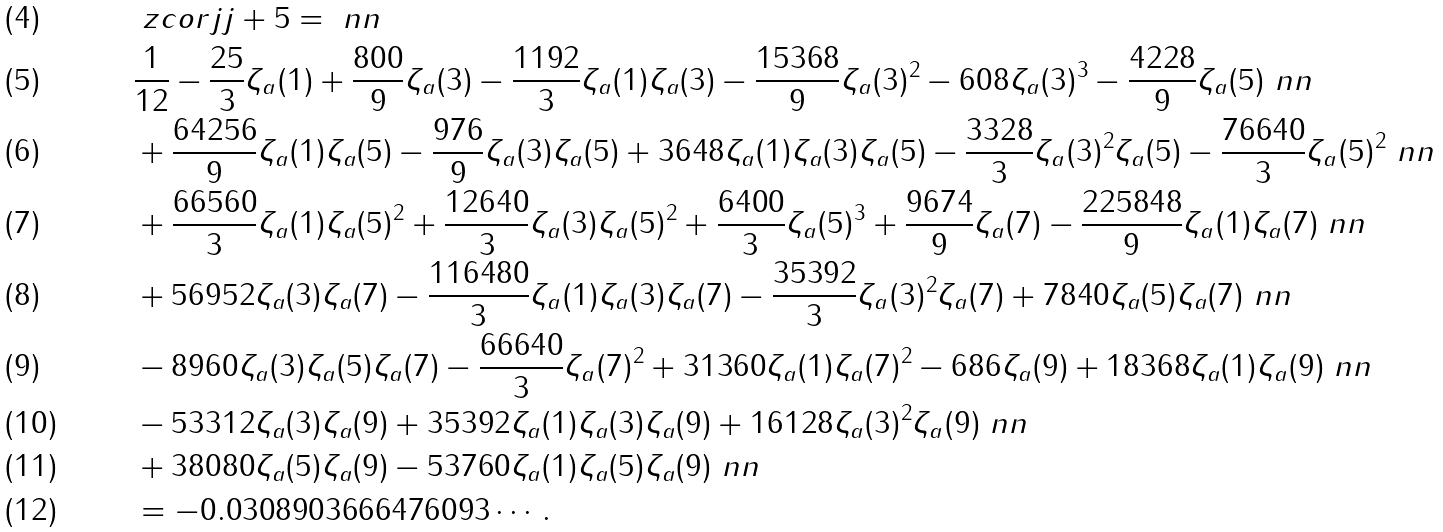Convert formula to latex. <formula><loc_0><loc_0><loc_500><loc_500>& \ z c o r { j } { j + 5 } = \ n n \\ & \frac { 1 } { 1 2 } - \frac { 2 5 } { 3 } \zeta _ { a } ( 1 ) + \frac { 8 0 0 } { 9 } \zeta _ { a } ( 3 ) - \frac { 1 1 9 2 } { 3 } \zeta _ { a } ( 1 ) \zeta _ { a } ( 3 ) - \frac { 1 5 3 6 8 } { 9 } \zeta _ { a } ( 3 ) ^ { 2 } - 6 0 8 \zeta _ { a } ( 3 ) ^ { 3 } - \frac { 4 2 2 8 } { 9 } \zeta _ { a } ( 5 ) \ n n \\ & + \frac { 6 4 2 5 6 } { 9 } \zeta _ { a } ( 1 ) \zeta _ { a } ( 5 ) - \frac { 9 7 6 } { 9 } \zeta _ { a } ( 3 ) \zeta _ { a } ( 5 ) + 3 6 4 8 \zeta _ { a } ( 1 ) \zeta _ { a } ( 3 ) \zeta _ { a } ( 5 ) - \frac { 3 3 2 8 } { 3 } \zeta _ { a } ( 3 ) ^ { 2 } \zeta _ { a } ( 5 ) - \frac { 7 6 6 4 0 } { 3 } \zeta _ { a } ( 5 ) ^ { 2 } \ n n \\ & + \frac { 6 6 5 6 0 } { 3 } \zeta _ { a } ( 1 ) \zeta _ { a } ( 5 ) ^ { 2 } + \frac { 1 2 6 4 0 } { 3 } \zeta _ { a } ( 3 ) \zeta _ { a } ( 5 ) ^ { 2 } + \frac { 6 4 0 0 } { 3 } \zeta _ { a } ( 5 ) ^ { 3 } + \frac { 9 6 7 4 } { 9 } \zeta _ { a } ( 7 ) - \frac { 2 2 5 8 4 8 } { 9 } \zeta _ { a } ( 1 ) \zeta _ { a } ( 7 ) \ n n \\ & + 5 6 9 5 2 \zeta _ { a } ( 3 ) \zeta _ { a } ( 7 ) - \frac { 1 1 6 4 8 0 } { 3 } \zeta _ { a } ( 1 ) \zeta _ { a } ( 3 ) \zeta _ { a } ( 7 ) - \frac { 3 5 3 9 2 } { 3 } \zeta _ { a } ( 3 ) ^ { 2 } \zeta _ { a } ( 7 ) + 7 8 4 0 \zeta _ { a } ( 5 ) \zeta _ { a } ( 7 ) \ n n \\ & - 8 9 6 0 \zeta _ { a } ( 3 ) \zeta _ { a } ( 5 ) \zeta _ { a } ( 7 ) - \frac { 6 6 6 4 0 } { 3 } \zeta _ { a } ( 7 ) ^ { 2 } + 3 1 3 6 0 \zeta _ { a } ( 1 ) \zeta _ { a } ( 7 ) ^ { 2 } - 6 8 6 \zeta _ { a } ( 9 ) + 1 8 3 6 8 \zeta _ { a } ( 1 ) \zeta _ { a } ( 9 ) \ n n \\ & - 5 3 3 1 2 \zeta _ { a } ( 3 ) \zeta _ { a } ( 9 ) + 3 5 3 9 2 \zeta _ { a } ( 1 ) \zeta _ { a } ( 3 ) \zeta _ { a } ( 9 ) + 1 6 1 2 8 \zeta _ { a } ( 3 ) ^ { 2 } \zeta _ { a } ( 9 ) \ n n \\ & + 3 8 0 8 0 \zeta _ { a } ( 5 ) \zeta _ { a } ( 9 ) - 5 3 7 6 0 \zeta _ { a } ( 1 ) \zeta _ { a } ( 5 ) \zeta _ { a } ( 9 ) \ n n \\ & = - 0 . 0 3 0 8 9 0 3 6 6 6 4 7 6 0 9 3 \cdots .</formula> 